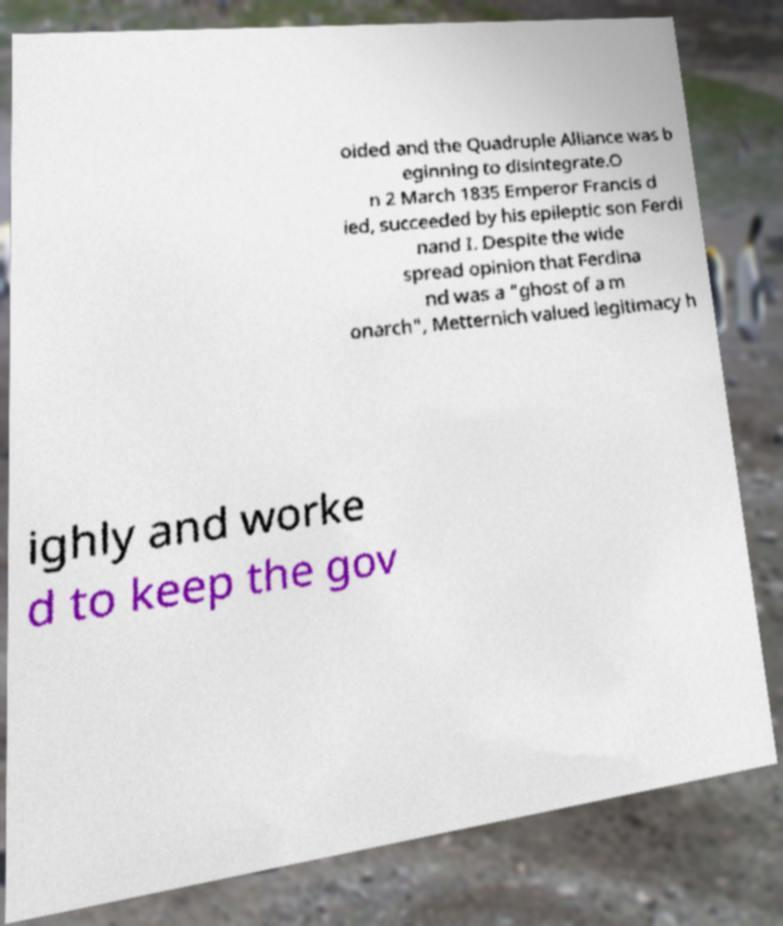What messages or text are displayed in this image? I need them in a readable, typed format. oided and the Quadruple Alliance was b eginning to disintegrate.O n 2 March 1835 Emperor Francis d ied, succeeded by his epileptic son Ferdi nand I. Despite the wide spread opinion that Ferdina nd was a "ghost of a m onarch", Metternich valued legitimacy h ighly and worke d to keep the gov 